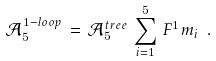Convert formula to latex. <formula><loc_0><loc_0><loc_500><loc_500>\mathcal { A } _ { 5 } ^ { 1 - l o o p } \, = \, \mathcal { A } _ { 5 } ^ { t r e e } \, \sum _ { i = 1 } ^ { 5 } \, F ^ { 1 } m _ { i } \ .</formula> 